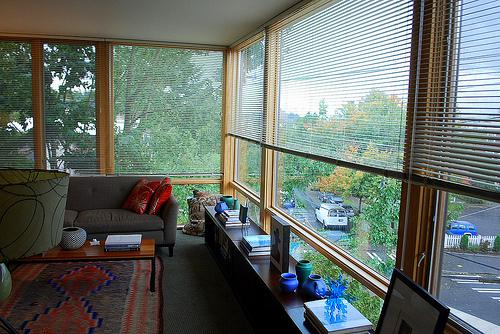Question: what is on the couch?
Choices:
A. Blankets.
B. People.
C. Clothes.
D. Throw pillows.
Answer with the letter. Answer: D Question: what are the colors of throw pillows?
Choices:
A. Blue.
B. Purple.
C. Red.
D. Pink.
Answer with the letter. Answer: C Question: who is sitting on the couch?
Choices:
A. 1 person.
B. 2 people.
C. 3 people.
D. No one.
Answer with the letter. Answer: D Question: where are the throw pillows?
Choices:
A. On the bed.
B. On the recliner.
C. On the floor.
D. On the couch.
Answer with the letter. Answer: D 